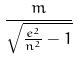Convert formula to latex. <formula><loc_0><loc_0><loc_500><loc_500>\frac { m } { \sqrt { \frac { e ^ { 2 } } { n ^ { 2 } } - 1 } }</formula> 